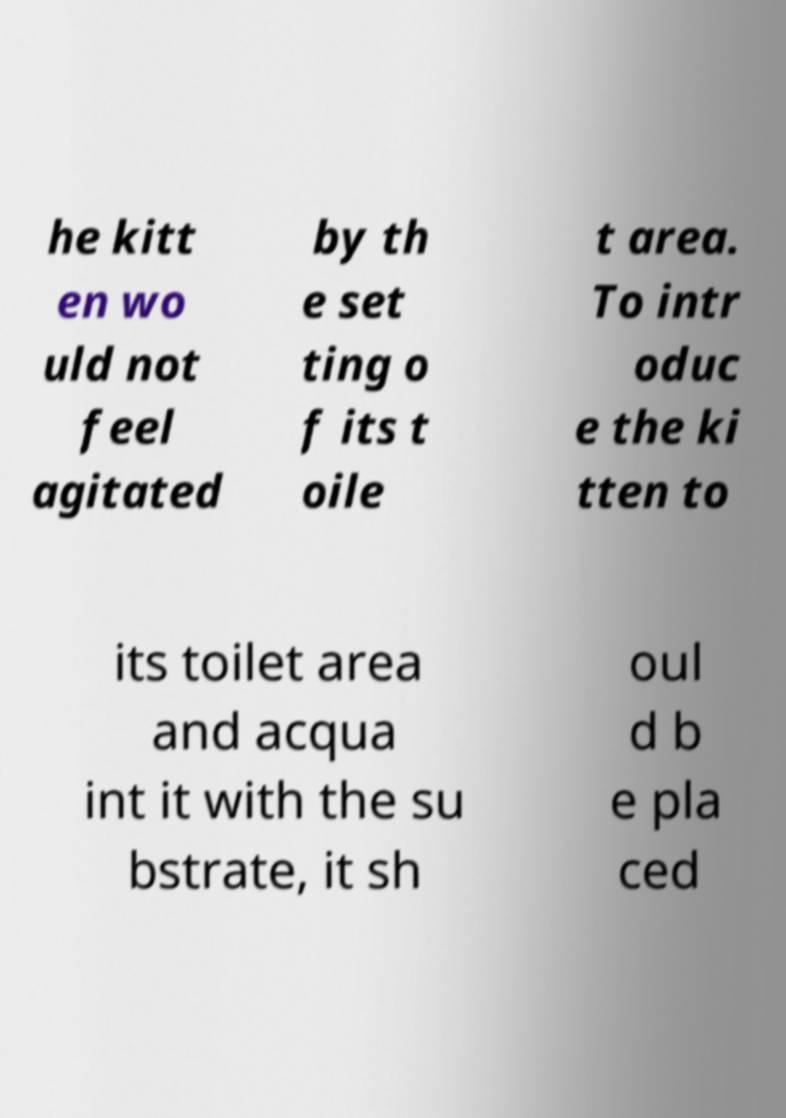Please identify and transcribe the text found in this image. he kitt en wo uld not feel agitated by th e set ting o f its t oile t area. To intr oduc e the ki tten to its toilet area and acqua int it with the su bstrate, it sh oul d b e pla ced 